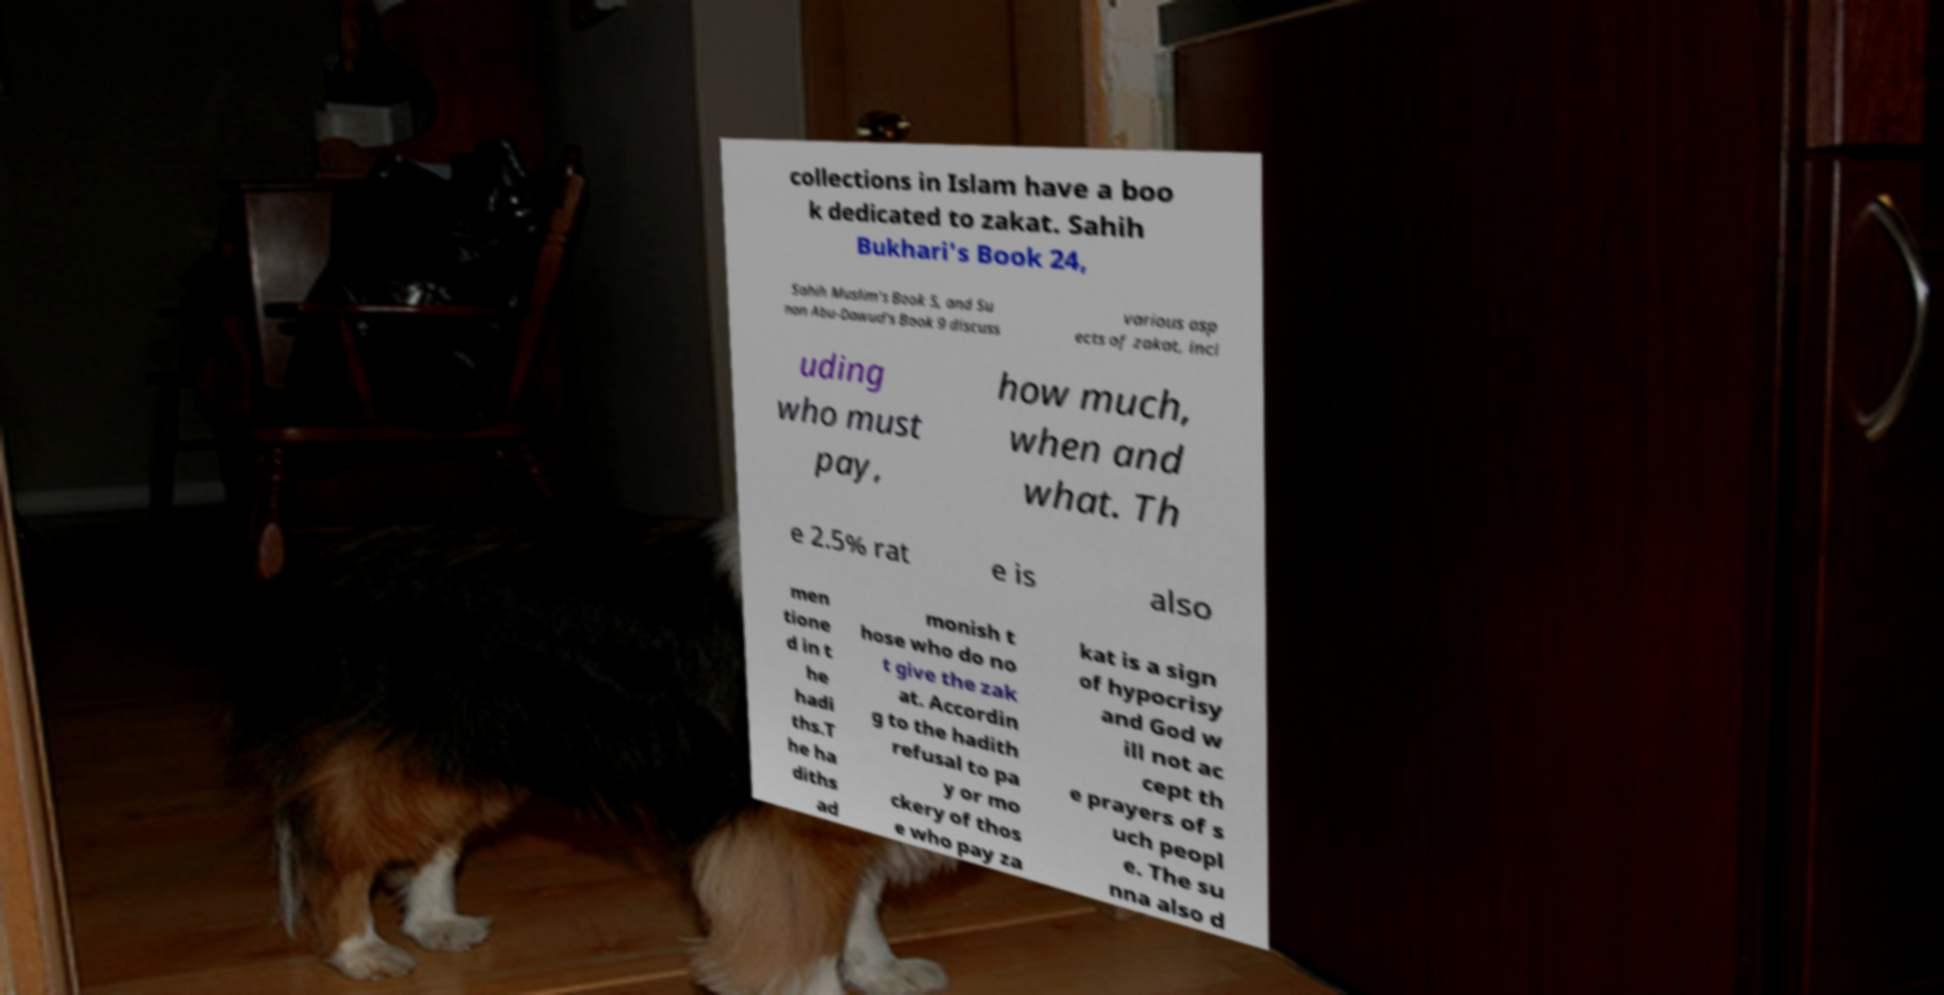I need the written content from this picture converted into text. Can you do that? collections in Islam have a boo k dedicated to zakat. Sahih Bukhari's Book 24, Sahih Muslim's Book 5, and Su nan Abu-Dawud's Book 9 discuss various asp ects of zakat, incl uding who must pay, how much, when and what. Th e 2.5% rat e is also men tione d in t he hadi ths.T he ha diths ad monish t hose who do no t give the zak at. Accordin g to the hadith refusal to pa y or mo ckery of thos e who pay za kat is a sign of hypocrisy and God w ill not ac cept th e prayers of s uch peopl e. The su nna also d 